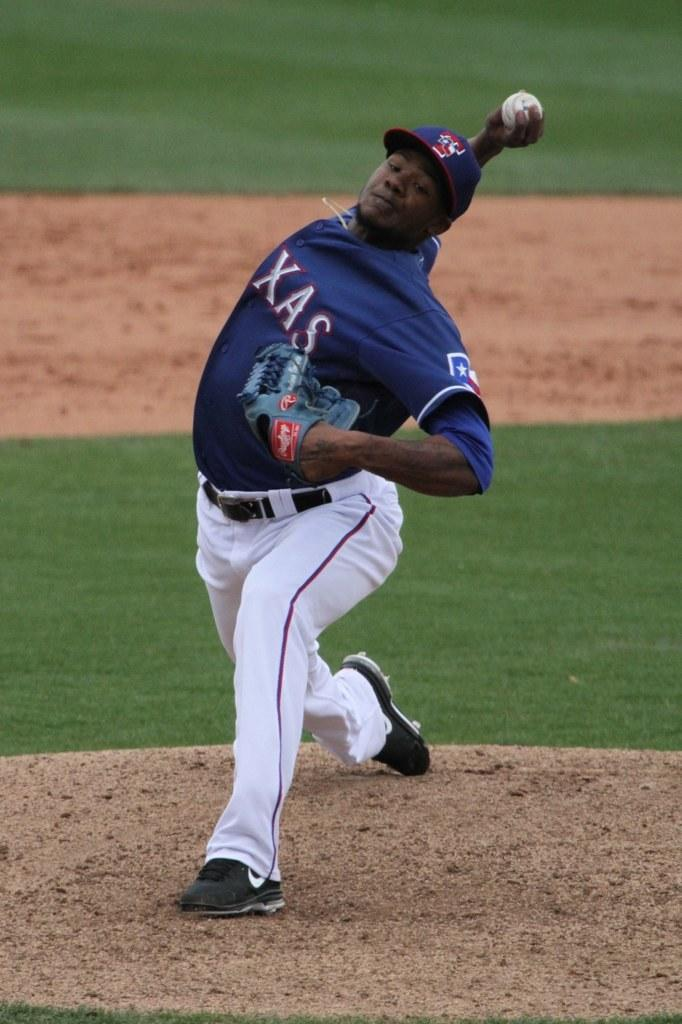<image>
Describe the image concisely. A pitcher for the Texas Rangers is at the pitchers mound, about to release the ball. 